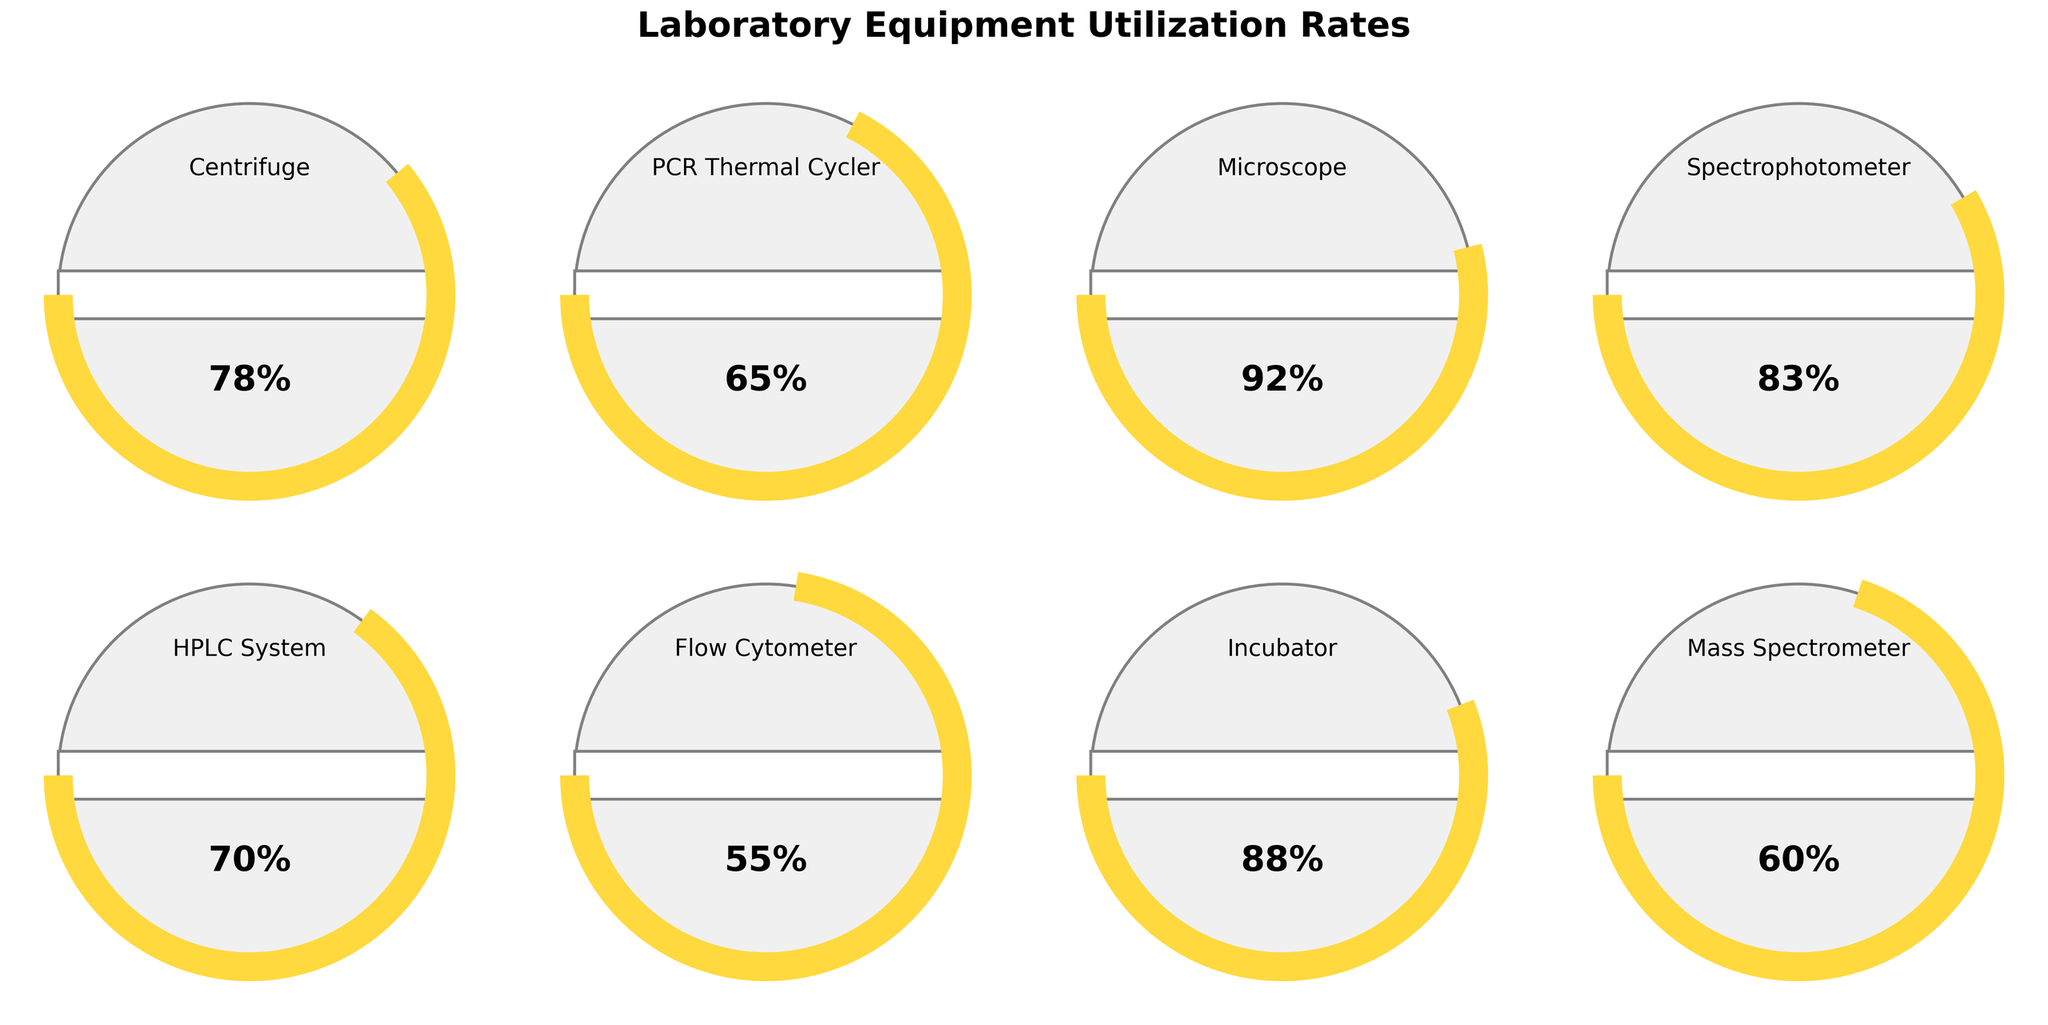What is the title of the figure? The title is located at the top of the figure in a larger, bold font, describing the overall subject of the plot. The exact text reads "Laboratory Equipment Utilization Rates".
Answer: Laboratory Equipment Utilization Rates How many different types of laboratory equipment are shown in the figure? There are eight gauge charts in the figure, each representing a different type of laboratory equipment, as indicated by their individual labels.
Answer: Eight Which laboratory equipment has the highest utilization rate? By examining each gauge chart, the microscope shows the highest utilization rate, with the percentage labeled as 92%.
Answer: Microscope What is the utilization rate of the Flow Cytometer? Locate the gauge labeled "Flow Cytometer" and observe the number displayed below the needle. It is marked as 55%.
Answer: 55% What is the average utilization rate of the listed equipment? To find the average, sum all the utilization rates (78 + 65 + 92 + 83 + 70 + 55 + 88 + 60) = 591, then divide by the number of equipment (8). The result is 591 / 8 = 73.875%.
Answer: 73.875% Which equipment has a utilization rate less than 70%? Reviewing each gauge, the flow cytometer (55%) and mass spectrometer (60%) both have utilization rates below 70%.
Answer: Flow Cytometer and Mass Spectrometer How does the utilization rate of the HPLC System compare to the Incubator? The gauge for the HPLC System shows a rate of 70%, while the Incubator has a rate of 88%. Thus, the Incubator's utilization rate is higher.
Answer: The Incubator has a higher rate Which range of colors is used for the gauge arcs? The arcs within the gauges use varying shades of colors from red at the lowest rates, yellow in the mid-range, to green at the highest rates as indicated by the color gradient visible on the arcs.
Answer: Red, Yellow, Green If the utilization rate needed to exceed 85% to be considered optimal, how many types of equipment meet this criteria? Identify the gauges with rates higher than 85%. The microscope (92%) and incubator (88%) exceed this threshold, so there are two.
Answer: Two What is the difference in utilization rates between the Centrifuge and Mass Spectrometer? Subtract the utilization rate of the Mass Spectrometer (60%) from that of the Centrifuge (78%), resulting in a difference of 78% - 60% = 18%.
Answer: 18 